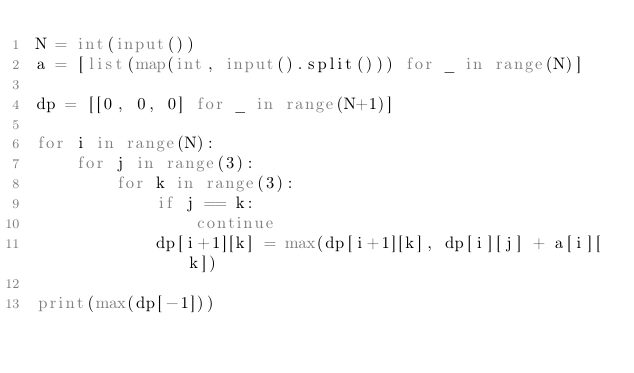Convert code to text. <code><loc_0><loc_0><loc_500><loc_500><_Python_>N = int(input())
a = [list(map(int, input().split())) for _ in range(N)]

dp = [[0, 0, 0] for _ in range(N+1)]

for i in range(N):
    for j in range(3):
        for k in range(3):
            if j == k:
                continue
            dp[i+1][k] = max(dp[i+1][k], dp[i][j] + a[i][k])

print(max(dp[-1]))
</code> 